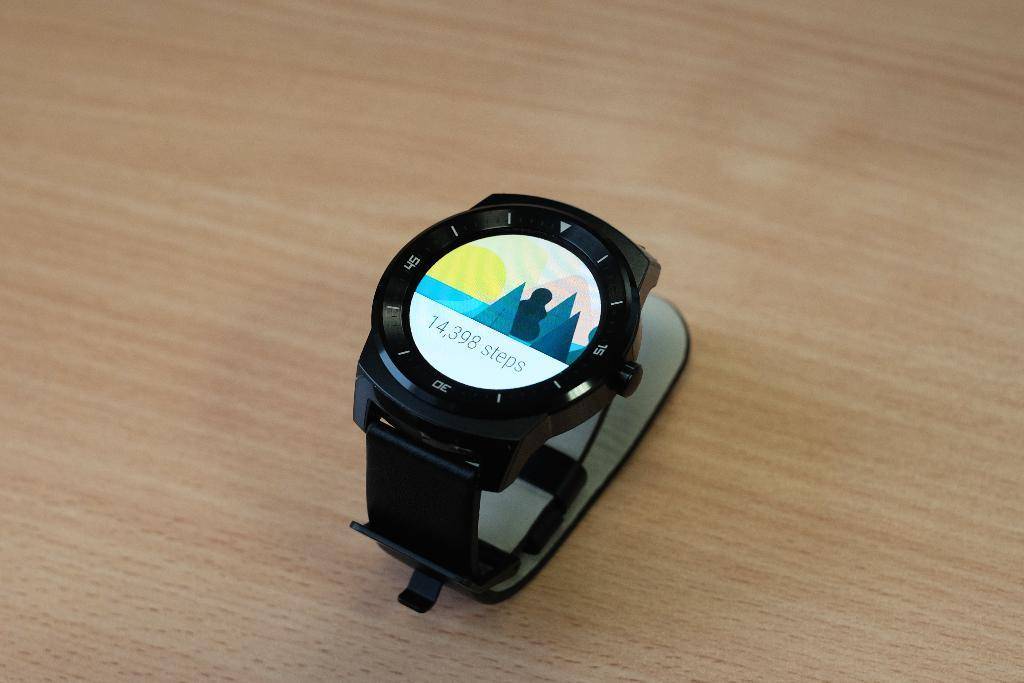<image>
Share a concise interpretation of the image provided. Watch that has a background of trees and counted 14,398 Steps. 